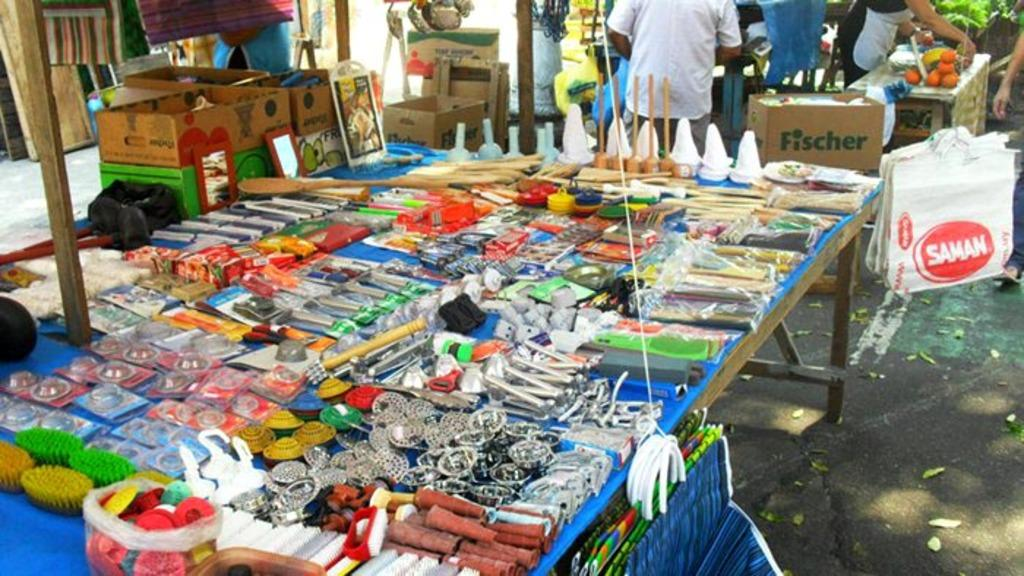How many people can be seen in the image? There are people in the image, but the exact number is not specified. What type of objects are present in the image along with the people? There are boxes, mirrors, and brushes in the image. Can you describe any other objects present in the image? There are other objects present in the image, but their specific nature is not mentioned. What type of pollution can be seen in the image? There is no mention of pollution in the image, so it cannot be determined from the facts provided. 